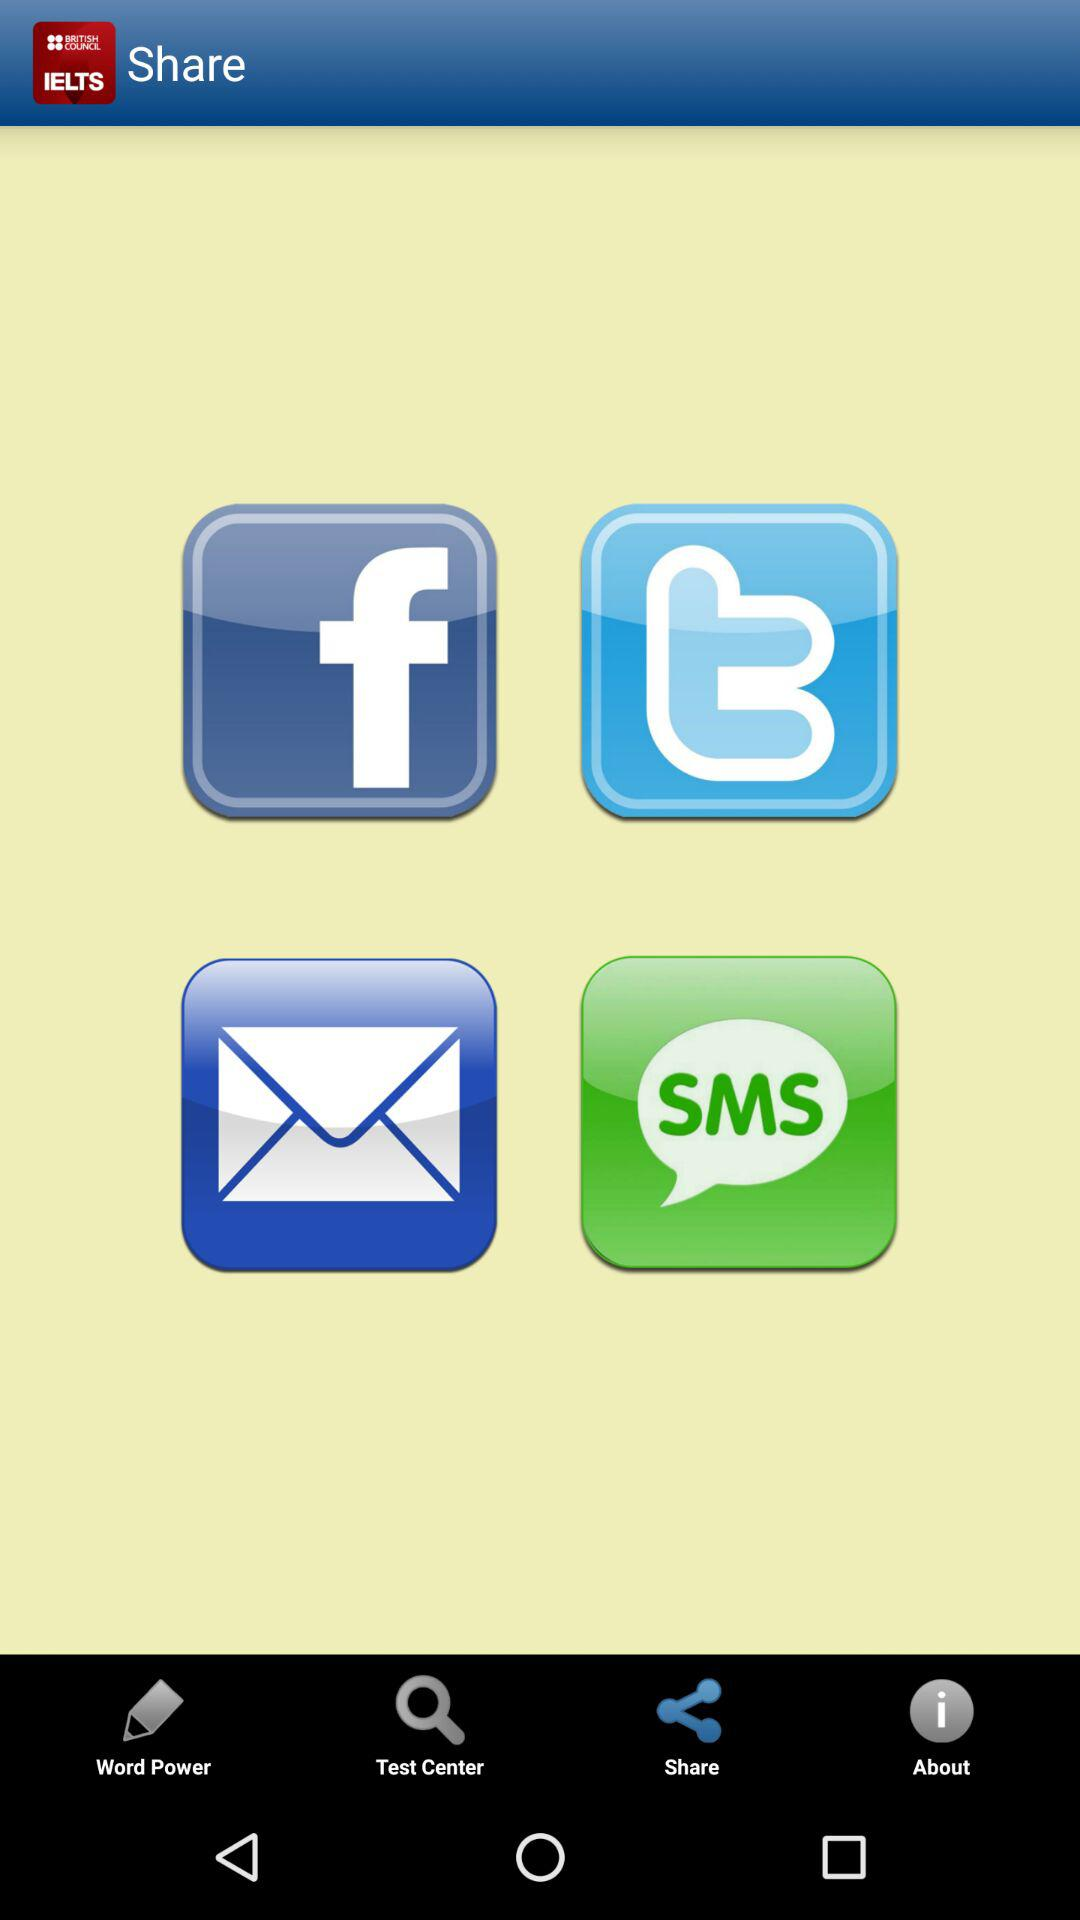What are the available sharing options? The sharing options are "Facebook", "Twitter", "Email" and "Bulk sms sender Excel,Text...". 